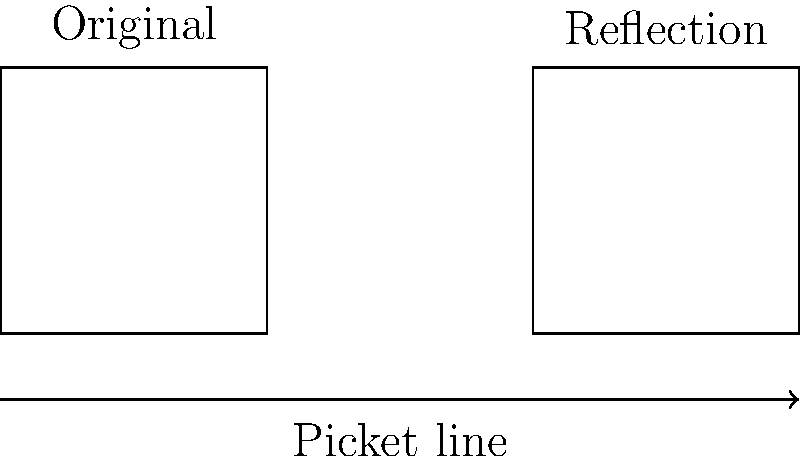A group of workers is planning to create rectangular protest signs for their picket line. They want to ensure that their signs will look the same when reflected across the picket line. If the original sign has dimensions of 2 units by 2 units, what will be the area of the reflected sign? To solve this problem, let's follow these steps:

1) First, recall that reflection preserves the shape and size of an object. This means that the reflected sign will have the same dimensions as the original sign.

2) The original sign has dimensions of 2 units by 2 units.

3) To calculate the area of a rectangle, we use the formula:
   
   $$ A = l \times w $$
   
   where $A$ is the area, $l$ is the length, and $w$ is the width.

4) Substituting the given dimensions:

   $$ A = 2 \times 2 = 4 $$

5) Therefore, the area of the reflected sign will also be 4 square units.

This reflection property is crucial in ensuring that the protest message remains consistent and visible from both sides of the picket line, symbolizing the unity and strength of the workers' movement.
Answer: 4 square units 